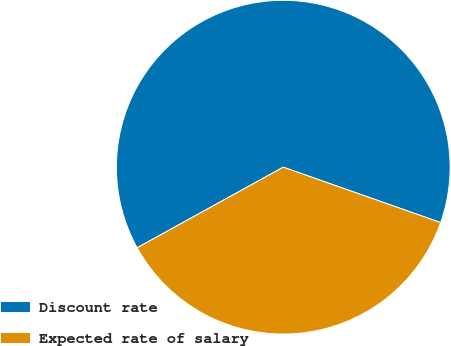<chart> <loc_0><loc_0><loc_500><loc_500><pie_chart><fcel>Discount rate<fcel>Expected rate of salary<nl><fcel>63.41%<fcel>36.59%<nl></chart> 